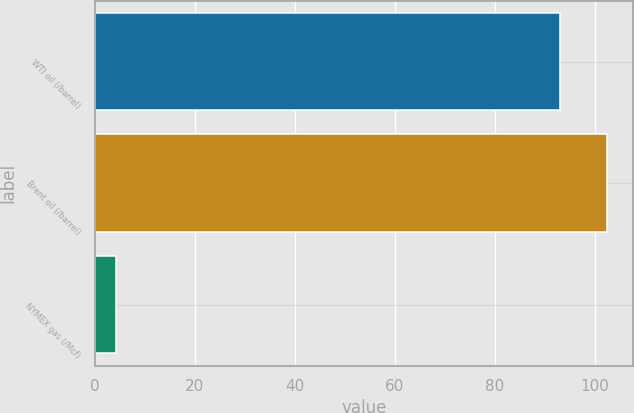<chart> <loc_0><loc_0><loc_500><loc_500><bar_chart><fcel>WTI oil (/barrel)<fcel>Brent oil (/barrel)<fcel>NYMEX gas (/Mcf)<nl><fcel>93<fcel>102.52<fcel>4.34<nl></chart> 